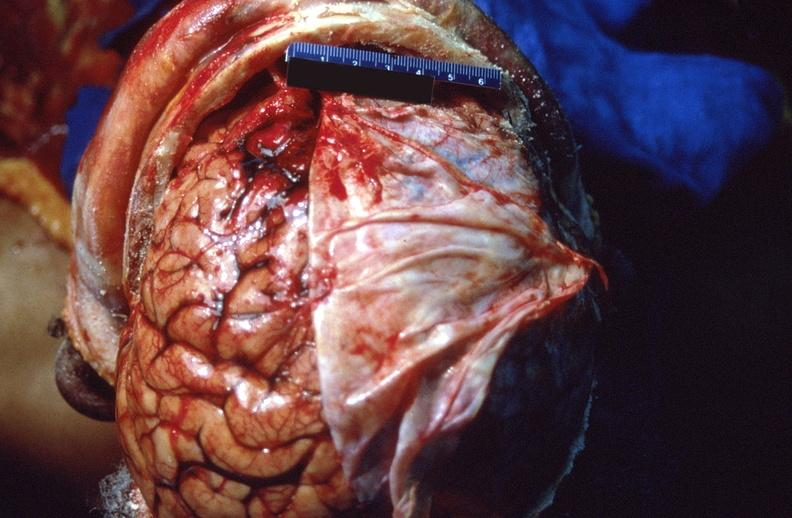does this image show brain, intracerebral hemorrhage?
Answer the question using a single word or phrase. Yes 